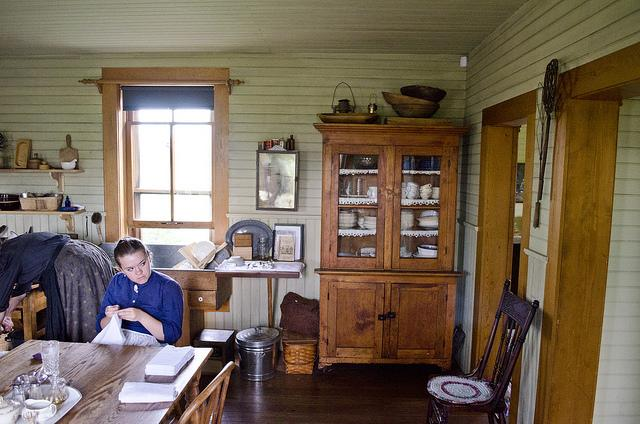What is this woman doing? Please explain your reasoning. folding napkins. The woman has a stack of napkins and is folding them. 